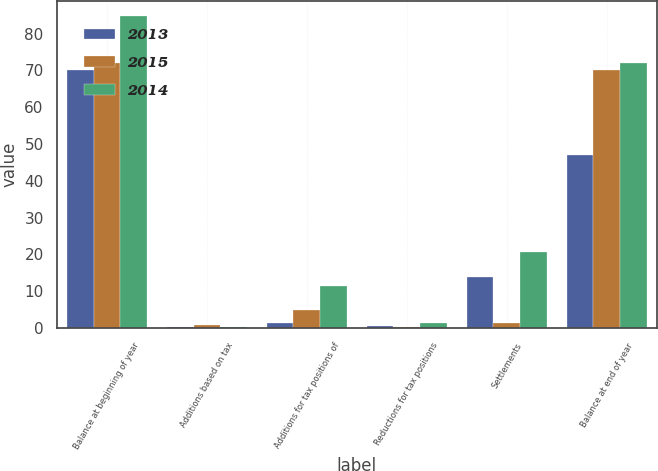<chart> <loc_0><loc_0><loc_500><loc_500><stacked_bar_chart><ecel><fcel>Balance at beginning of year<fcel>Additions based on tax<fcel>Additions for tax positions of<fcel>Reductions for tax positions<fcel>Settlements<fcel>Balance at end of year<nl><fcel>2013<fcel>70.1<fcel>0.2<fcel>1.4<fcel>0.6<fcel>13.9<fcel>47<nl><fcel>2015<fcel>72<fcel>0.8<fcel>5<fcel>0.2<fcel>1.5<fcel>70.1<nl><fcel>2014<fcel>84.7<fcel>0.3<fcel>11.4<fcel>1.3<fcel>20.7<fcel>72<nl></chart> 